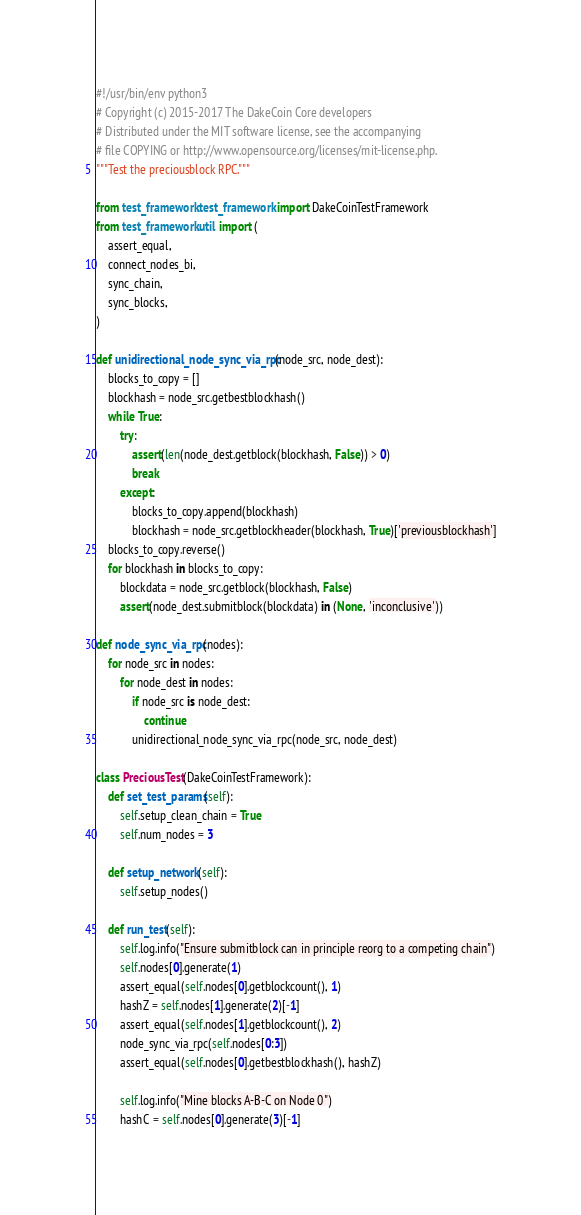<code> <loc_0><loc_0><loc_500><loc_500><_Python_>#!/usr/bin/env python3
# Copyright (c) 2015-2017 The DakeCoin Core developers
# Distributed under the MIT software license, see the accompanying
# file COPYING or http://www.opensource.org/licenses/mit-license.php.
"""Test the preciousblock RPC."""

from test_framework.test_framework import DakeCoinTestFramework
from test_framework.util import (
    assert_equal,
    connect_nodes_bi,
    sync_chain,
    sync_blocks,
)

def unidirectional_node_sync_via_rpc(node_src, node_dest):
    blocks_to_copy = []
    blockhash = node_src.getbestblockhash()
    while True:
        try:
            assert(len(node_dest.getblock(blockhash, False)) > 0)
            break
        except:
            blocks_to_copy.append(blockhash)
            blockhash = node_src.getblockheader(blockhash, True)['previousblockhash']
    blocks_to_copy.reverse()
    for blockhash in blocks_to_copy:
        blockdata = node_src.getblock(blockhash, False)
        assert(node_dest.submitblock(blockdata) in (None, 'inconclusive'))

def node_sync_via_rpc(nodes):
    for node_src in nodes:
        for node_dest in nodes:
            if node_src is node_dest:
                continue
            unidirectional_node_sync_via_rpc(node_src, node_dest)

class PreciousTest(DakeCoinTestFramework):
    def set_test_params(self):
        self.setup_clean_chain = True
        self.num_nodes = 3

    def setup_network(self):
        self.setup_nodes()

    def run_test(self):
        self.log.info("Ensure submitblock can in principle reorg to a competing chain")
        self.nodes[0].generate(1)
        assert_equal(self.nodes[0].getblockcount(), 1)
        hashZ = self.nodes[1].generate(2)[-1]
        assert_equal(self.nodes[1].getblockcount(), 2)
        node_sync_via_rpc(self.nodes[0:3])
        assert_equal(self.nodes[0].getbestblockhash(), hashZ)

        self.log.info("Mine blocks A-B-C on Node 0")
        hashC = self.nodes[0].generate(3)[-1]</code> 